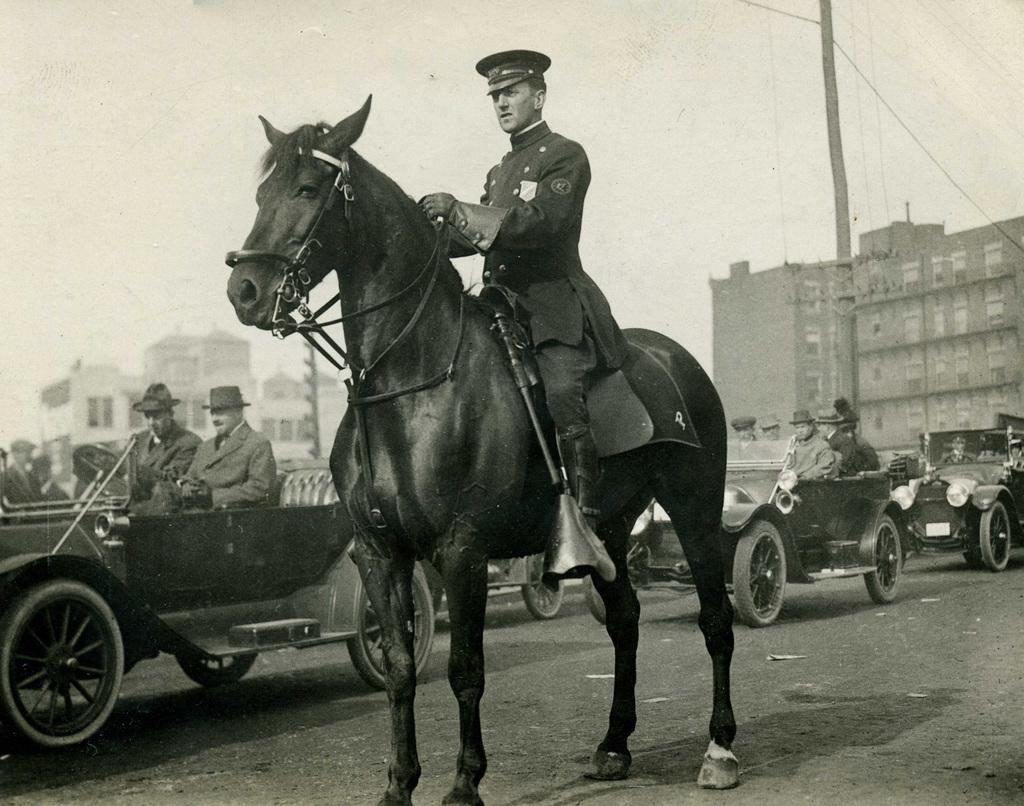What is the man in the image doing? The man is sitting on a horse in the image. What else can be seen in the image besides the man on the horse? There is a car with two men sitting inside, a building in the background, and a pole in the background. What type of seat is the man on the horse using? The man is not using a seat; he is sitting directly on the horse. How many tanks are visible in the image? There are no tanks present in the image. 